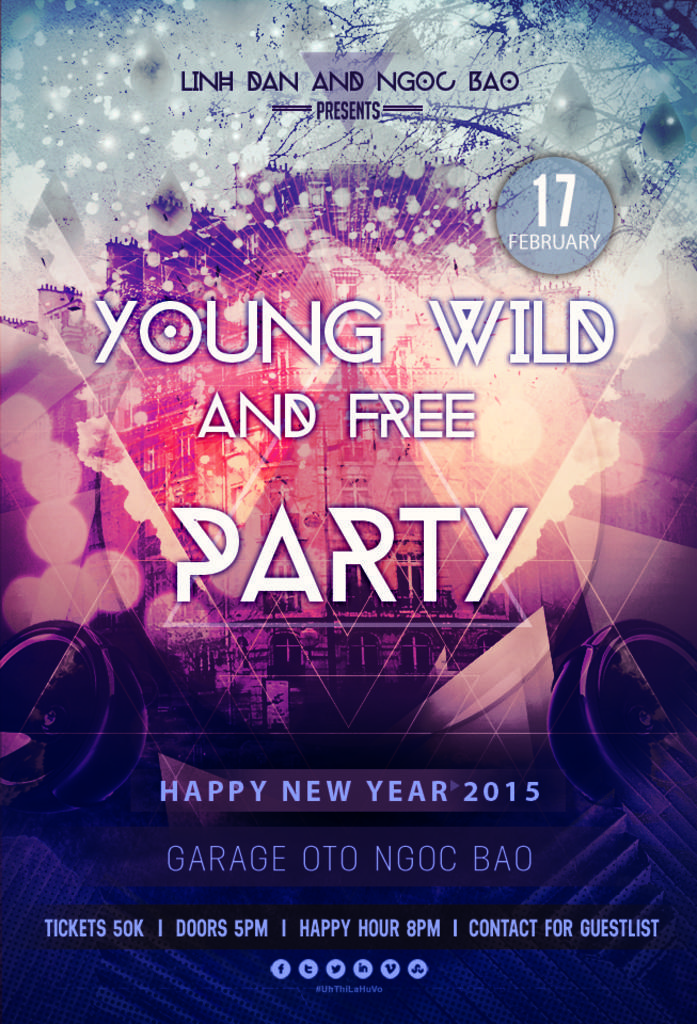Describe this image in one or two sentences. In this image we can see advertisement. In this image we can see text. In the background there is building. 